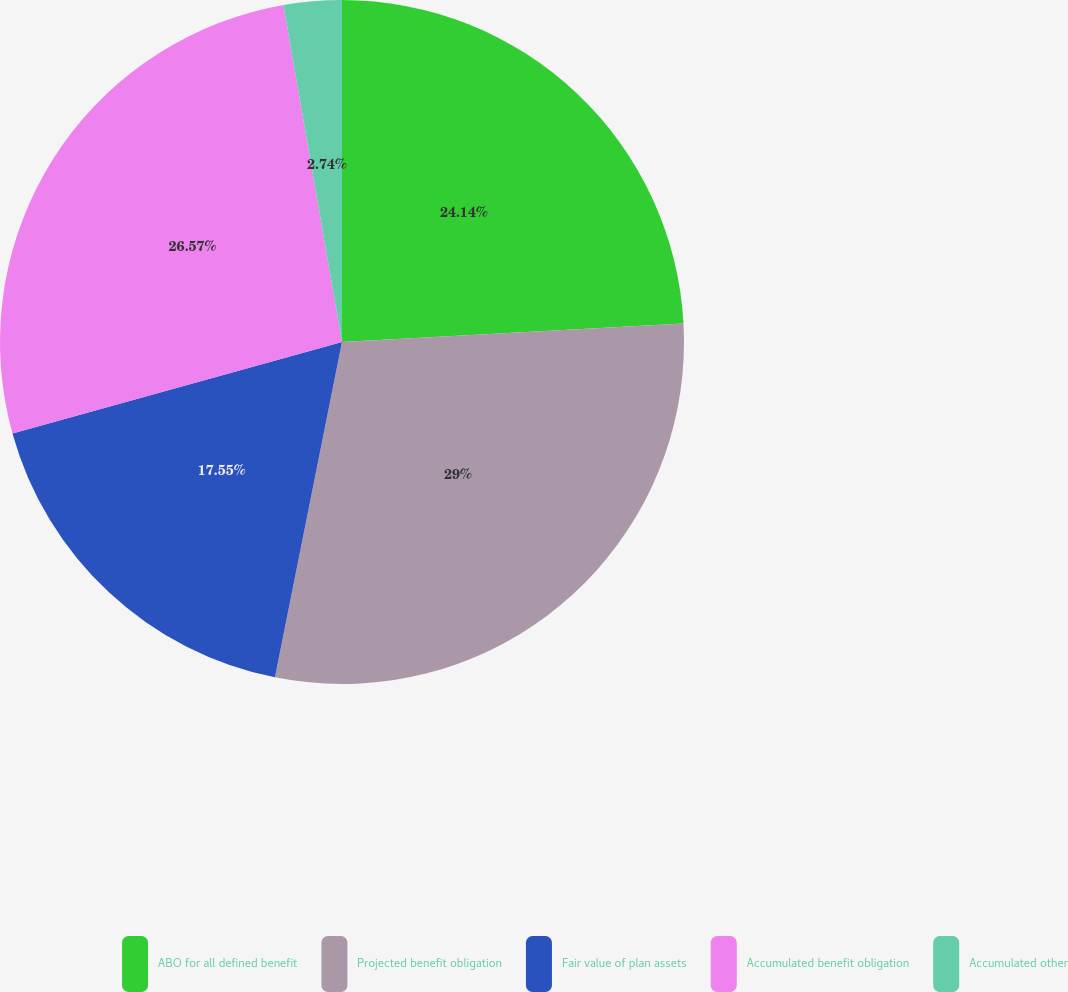Convert chart. <chart><loc_0><loc_0><loc_500><loc_500><pie_chart><fcel>ABO for all defined benefit<fcel>Projected benefit obligation<fcel>Fair value of plan assets<fcel>Accumulated benefit obligation<fcel>Accumulated other<nl><fcel>24.14%<fcel>29.0%<fcel>17.55%<fcel>26.57%<fcel>2.74%<nl></chart> 